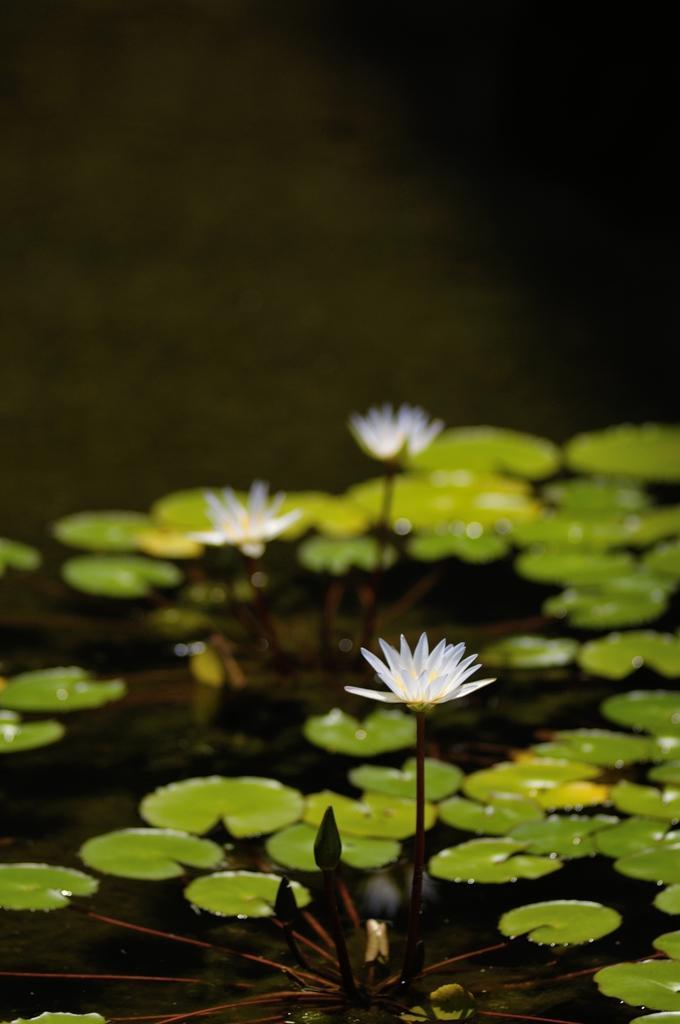In one or two sentences, can you explain what this image depicts? In this image there are leaves and flowers on the surface of the water. 